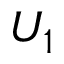<formula> <loc_0><loc_0><loc_500><loc_500>U _ { 1 }</formula> 